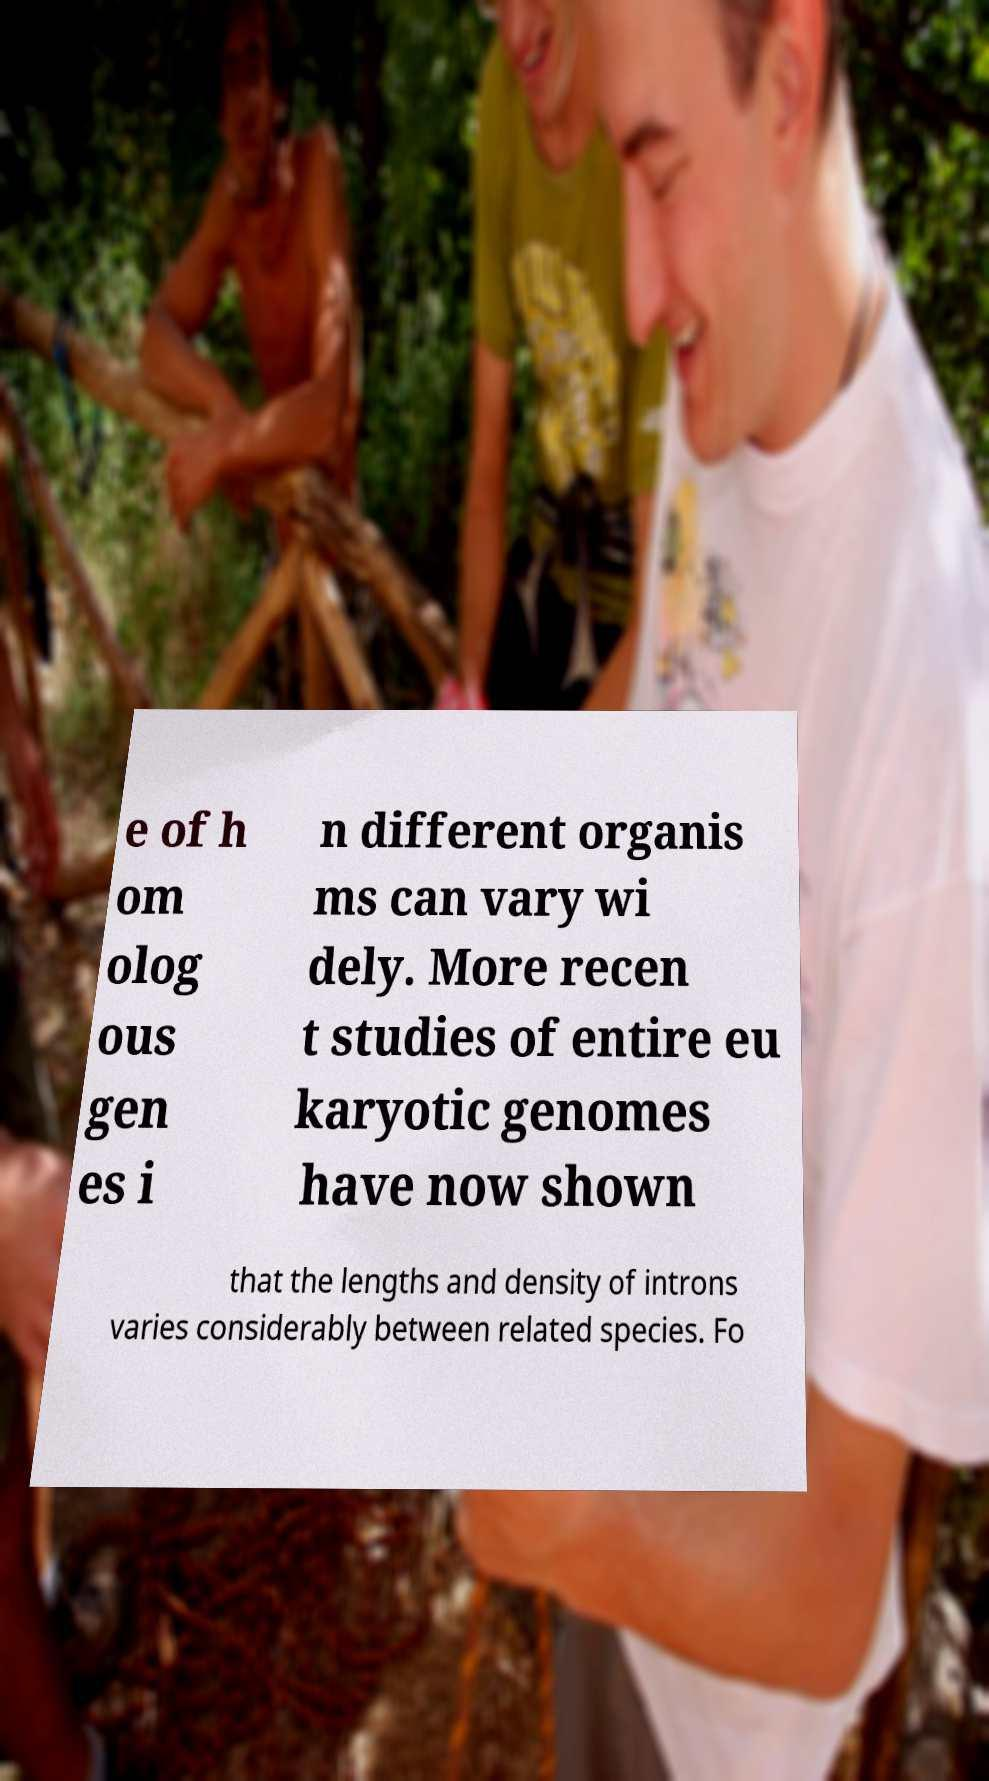What messages or text are displayed in this image? I need them in a readable, typed format. e of h om olog ous gen es i n different organis ms can vary wi dely. More recen t studies of entire eu karyotic genomes have now shown that the lengths and density of introns varies considerably between related species. Fo 